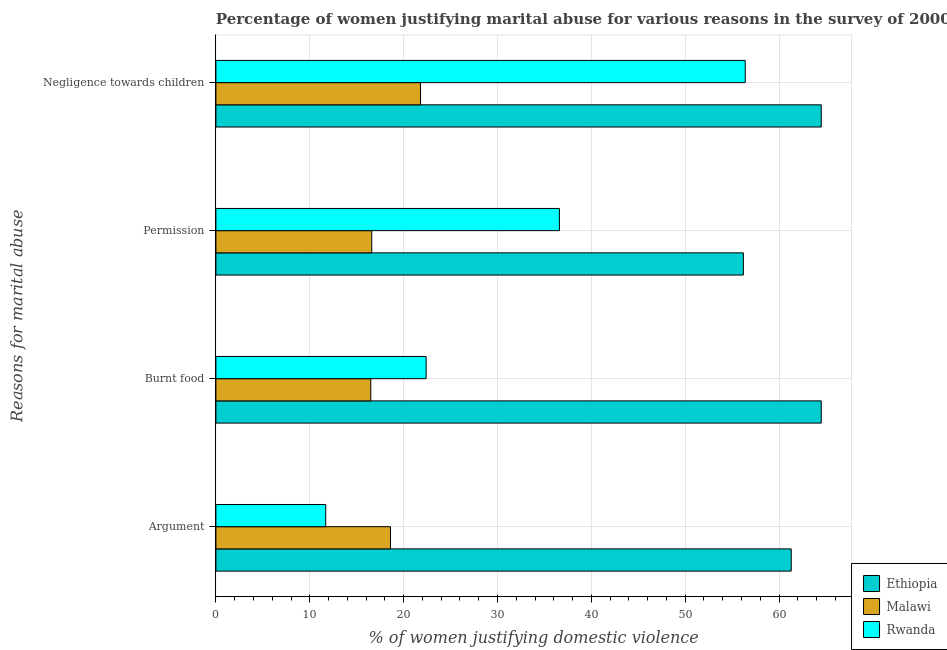How many groups of bars are there?
Offer a very short reply. 4. Are the number of bars per tick equal to the number of legend labels?
Ensure brevity in your answer.  Yes. Are the number of bars on each tick of the Y-axis equal?
Ensure brevity in your answer.  Yes. What is the label of the 3rd group of bars from the top?
Make the answer very short. Burnt food. What is the percentage of women justifying abuse for showing negligence towards children in Rwanda?
Ensure brevity in your answer.  56.4. Across all countries, what is the maximum percentage of women justifying abuse in the case of an argument?
Ensure brevity in your answer.  61.3. Across all countries, what is the minimum percentage of women justifying abuse for showing negligence towards children?
Ensure brevity in your answer.  21.8. In which country was the percentage of women justifying abuse in the case of an argument maximum?
Your answer should be compact. Ethiopia. In which country was the percentage of women justifying abuse for going without permission minimum?
Keep it short and to the point. Malawi. What is the total percentage of women justifying abuse for going without permission in the graph?
Your answer should be compact. 109.4. What is the difference between the percentage of women justifying abuse for showing negligence towards children in Rwanda and that in Ethiopia?
Provide a succinct answer. -8.1. What is the difference between the percentage of women justifying abuse for going without permission in Ethiopia and the percentage of women justifying abuse in the case of an argument in Rwanda?
Your response must be concise. 44.5. What is the average percentage of women justifying abuse for showing negligence towards children per country?
Provide a succinct answer. 47.57. What is the difference between the percentage of women justifying abuse for burning food and percentage of women justifying abuse for going without permission in Rwanda?
Keep it short and to the point. -14.2. What is the ratio of the percentage of women justifying abuse in the case of an argument in Malawi to that in Ethiopia?
Offer a terse response. 0.3. Is the difference between the percentage of women justifying abuse in the case of an argument in Ethiopia and Malawi greater than the difference between the percentage of women justifying abuse for going without permission in Ethiopia and Malawi?
Ensure brevity in your answer.  Yes. What is the difference between the highest and the second highest percentage of women justifying abuse for going without permission?
Provide a short and direct response. 19.6. Is the sum of the percentage of women justifying abuse in the case of an argument in Malawi and Ethiopia greater than the maximum percentage of women justifying abuse for going without permission across all countries?
Offer a very short reply. Yes. What does the 1st bar from the top in Negligence towards children represents?
Give a very brief answer. Rwanda. What does the 1st bar from the bottom in Negligence towards children represents?
Provide a succinct answer. Ethiopia. Does the graph contain any zero values?
Make the answer very short. No. Does the graph contain grids?
Provide a short and direct response. Yes. How are the legend labels stacked?
Offer a very short reply. Vertical. What is the title of the graph?
Keep it short and to the point. Percentage of women justifying marital abuse for various reasons in the survey of 2000. What is the label or title of the X-axis?
Provide a succinct answer. % of women justifying domestic violence. What is the label or title of the Y-axis?
Ensure brevity in your answer.  Reasons for marital abuse. What is the % of women justifying domestic violence of Ethiopia in Argument?
Offer a terse response. 61.3. What is the % of women justifying domestic violence in Rwanda in Argument?
Provide a succinct answer. 11.7. What is the % of women justifying domestic violence of Ethiopia in Burnt food?
Your response must be concise. 64.5. What is the % of women justifying domestic violence in Malawi in Burnt food?
Make the answer very short. 16.5. What is the % of women justifying domestic violence of Rwanda in Burnt food?
Provide a short and direct response. 22.4. What is the % of women justifying domestic violence of Ethiopia in Permission?
Give a very brief answer. 56.2. What is the % of women justifying domestic violence of Rwanda in Permission?
Provide a short and direct response. 36.6. What is the % of women justifying domestic violence of Ethiopia in Negligence towards children?
Give a very brief answer. 64.5. What is the % of women justifying domestic violence in Malawi in Negligence towards children?
Offer a very short reply. 21.8. What is the % of women justifying domestic violence of Rwanda in Negligence towards children?
Ensure brevity in your answer.  56.4. Across all Reasons for marital abuse, what is the maximum % of women justifying domestic violence of Ethiopia?
Ensure brevity in your answer.  64.5. Across all Reasons for marital abuse, what is the maximum % of women justifying domestic violence in Malawi?
Offer a terse response. 21.8. Across all Reasons for marital abuse, what is the maximum % of women justifying domestic violence in Rwanda?
Provide a short and direct response. 56.4. Across all Reasons for marital abuse, what is the minimum % of women justifying domestic violence of Ethiopia?
Provide a succinct answer. 56.2. Across all Reasons for marital abuse, what is the minimum % of women justifying domestic violence of Malawi?
Keep it short and to the point. 16.5. Across all Reasons for marital abuse, what is the minimum % of women justifying domestic violence of Rwanda?
Your response must be concise. 11.7. What is the total % of women justifying domestic violence in Ethiopia in the graph?
Provide a succinct answer. 246.5. What is the total % of women justifying domestic violence in Malawi in the graph?
Give a very brief answer. 73.5. What is the total % of women justifying domestic violence in Rwanda in the graph?
Your answer should be compact. 127.1. What is the difference between the % of women justifying domestic violence of Ethiopia in Argument and that in Burnt food?
Your response must be concise. -3.2. What is the difference between the % of women justifying domestic violence of Rwanda in Argument and that in Burnt food?
Ensure brevity in your answer.  -10.7. What is the difference between the % of women justifying domestic violence in Malawi in Argument and that in Permission?
Provide a succinct answer. 2. What is the difference between the % of women justifying domestic violence of Rwanda in Argument and that in Permission?
Keep it short and to the point. -24.9. What is the difference between the % of women justifying domestic violence in Ethiopia in Argument and that in Negligence towards children?
Keep it short and to the point. -3.2. What is the difference between the % of women justifying domestic violence of Malawi in Argument and that in Negligence towards children?
Your answer should be compact. -3.2. What is the difference between the % of women justifying domestic violence in Rwanda in Argument and that in Negligence towards children?
Keep it short and to the point. -44.7. What is the difference between the % of women justifying domestic violence of Ethiopia in Burnt food and that in Permission?
Provide a succinct answer. 8.3. What is the difference between the % of women justifying domestic violence of Malawi in Burnt food and that in Permission?
Offer a terse response. -0.1. What is the difference between the % of women justifying domestic violence of Rwanda in Burnt food and that in Permission?
Make the answer very short. -14.2. What is the difference between the % of women justifying domestic violence in Ethiopia in Burnt food and that in Negligence towards children?
Your answer should be compact. 0. What is the difference between the % of women justifying domestic violence in Rwanda in Burnt food and that in Negligence towards children?
Offer a terse response. -34. What is the difference between the % of women justifying domestic violence of Rwanda in Permission and that in Negligence towards children?
Offer a very short reply. -19.8. What is the difference between the % of women justifying domestic violence in Ethiopia in Argument and the % of women justifying domestic violence in Malawi in Burnt food?
Give a very brief answer. 44.8. What is the difference between the % of women justifying domestic violence in Ethiopia in Argument and the % of women justifying domestic violence in Rwanda in Burnt food?
Your answer should be compact. 38.9. What is the difference between the % of women justifying domestic violence in Malawi in Argument and the % of women justifying domestic violence in Rwanda in Burnt food?
Make the answer very short. -3.8. What is the difference between the % of women justifying domestic violence in Ethiopia in Argument and the % of women justifying domestic violence in Malawi in Permission?
Keep it short and to the point. 44.7. What is the difference between the % of women justifying domestic violence of Ethiopia in Argument and the % of women justifying domestic violence of Rwanda in Permission?
Keep it short and to the point. 24.7. What is the difference between the % of women justifying domestic violence in Malawi in Argument and the % of women justifying domestic violence in Rwanda in Permission?
Provide a short and direct response. -18. What is the difference between the % of women justifying domestic violence in Ethiopia in Argument and the % of women justifying domestic violence in Malawi in Negligence towards children?
Your answer should be very brief. 39.5. What is the difference between the % of women justifying domestic violence of Ethiopia in Argument and the % of women justifying domestic violence of Rwanda in Negligence towards children?
Offer a very short reply. 4.9. What is the difference between the % of women justifying domestic violence in Malawi in Argument and the % of women justifying domestic violence in Rwanda in Negligence towards children?
Provide a short and direct response. -37.8. What is the difference between the % of women justifying domestic violence in Ethiopia in Burnt food and the % of women justifying domestic violence in Malawi in Permission?
Keep it short and to the point. 47.9. What is the difference between the % of women justifying domestic violence of Ethiopia in Burnt food and the % of women justifying domestic violence of Rwanda in Permission?
Offer a very short reply. 27.9. What is the difference between the % of women justifying domestic violence in Malawi in Burnt food and the % of women justifying domestic violence in Rwanda in Permission?
Ensure brevity in your answer.  -20.1. What is the difference between the % of women justifying domestic violence of Ethiopia in Burnt food and the % of women justifying domestic violence of Malawi in Negligence towards children?
Make the answer very short. 42.7. What is the difference between the % of women justifying domestic violence of Ethiopia in Burnt food and the % of women justifying domestic violence of Rwanda in Negligence towards children?
Offer a very short reply. 8.1. What is the difference between the % of women justifying domestic violence of Malawi in Burnt food and the % of women justifying domestic violence of Rwanda in Negligence towards children?
Provide a short and direct response. -39.9. What is the difference between the % of women justifying domestic violence in Ethiopia in Permission and the % of women justifying domestic violence in Malawi in Negligence towards children?
Provide a succinct answer. 34.4. What is the difference between the % of women justifying domestic violence in Ethiopia in Permission and the % of women justifying domestic violence in Rwanda in Negligence towards children?
Provide a succinct answer. -0.2. What is the difference between the % of women justifying domestic violence of Malawi in Permission and the % of women justifying domestic violence of Rwanda in Negligence towards children?
Provide a succinct answer. -39.8. What is the average % of women justifying domestic violence of Ethiopia per Reasons for marital abuse?
Provide a succinct answer. 61.62. What is the average % of women justifying domestic violence in Malawi per Reasons for marital abuse?
Your answer should be very brief. 18.38. What is the average % of women justifying domestic violence in Rwanda per Reasons for marital abuse?
Ensure brevity in your answer.  31.77. What is the difference between the % of women justifying domestic violence in Ethiopia and % of women justifying domestic violence in Malawi in Argument?
Your answer should be very brief. 42.7. What is the difference between the % of women justifying domestic violence in Ethiopia and % of women justifying domestic violence in Rwanda in Argument?
Your response must be concise. 49.6. What is the difference between the % of women justifying domestic violence of Malawi and % of women justifying domestic violence of Rwanda in Argument?
Ensure brevity in your answer.  6.9. What is the difference between the % of women justifying domestic violence of Ethiopia and % of women justifying domestic violence of Rwanda in Burnt food?
Offer a terse response. 42.1. What is the difference between the % of women justifying domestic violence of Ethiopia and % of women justifying domestic violence of Malawi in Permission?
Ensure brevity in your answer.  39.6. What is the difference between the % of women justifying domestic violence in Ethiopia and % of women justifying domestic violence in Rwanda in Permission?
Your response must be concise. 19.6. What is the difference between the % of women justifying domestic violence in Ethiopia and % of women justifying domestic violence in Malawi in Negligence towards children?
Offer a very short reply. 42.7. What is the difference between the % of women justifying domestic violence of Ethiopia and % of women justifying domestic violence of Rwanda in Negligence towards children?
Keep it short and to the point. 8.1. What is the difference between the % of women justifying domestic violence in Malawi and % of women justifying domestic violence in Rwanda in Negligence towards children?
Keep it short and to the point. -34.6. What is the ratio of the % of women justifying domestic violence in Ethiopia in Argument to that in Burnt food?
Your answer should be very brief. 0.95. What is the ratio of the % of women justifying domestic violence in Malawi in Argument to that in Burnt food?
Offer a very short reply. 1.13. What is the ratio of the % of women justifying domestic violence of Rwanda in Argument to that in Burnt food?
Provide a short and direct response. 0.52. What is the ratio of the % of women justifying domestic violence of Ethiopia in Argument to that in Permission?
Provide a short and direct response. 1.09. What is the ratio of the % of women justifying domestic violence in Malawi in Argument to that in Permission?
Your answer should be very brief. 1.12. What is the ratio of the % of women justifying domestic violence of Rwanda in Argument to that in Permission?
Ensure brevity in your answer.  0.32. What is the ratio of the % of women justifying domestic violence in Ethiopia in Argument to that in Negligence towards children?
Offer a very short reply. 0.95. What is the ratio of the % of women justifying domestic violence of Malawi in Argument to that in Negligence towards children?
Your answer should be very brief. 0.85. What is the ratio of the % of women justifying domestic violence in Rwanda in Argument to that in Negligence towards children?
Provide a succinct answer. 0.21. What is the ratio of the % of women justifying domestic violence of Ethiopia in Burnt food to that in Permission?
Your response must be concise. 1.15. What is the ratio of the % of women justifying domestic violence in Rwanda in Burnt food to that in Permission?
Provide a succinct answer. 0.61. What is the ratio of the % of women justifying domestic violence in Ethiopia in Burnt food to that in Negligence towards children?
Your response must be concise. 1. What is the ratio of the % of women justifying domestic violence in Malawi in Burnt food to that in Negligence towards children?
Provide a succinct answer. 0.76. What is the ratio of the % of women justifying domestic violence of Rwanda in Burnt food to that in Negligence towards children?
Offer a terse response. 0.4. What is the ratio of the % of women justifying domestic violence of Ethiopia in Permission to that in Negligence towards children?
Offer a very short reply. 0.87. What is the ratio of the % of women justifying domestic violence in Malawi in Permission to that in Negligence towards children?
Give a very brief answer. 0.76. What is the ratio of the % of women justifying domestic violence of Rwanda in Permission to that in Negligence towards children?
Provide a succinct answer. 0.65. What is the difference between the highest and the second highest % of women justifying domestic violence in Ethiopia?
Provide a short and direct response. 0. What is the difference between the highest and the second highest % of women justifying domestic violence of Rwanda?
Keep it short and to the point. 19.8. What is the difference between the highest and the lowest % of women justifying domestic violence in Ethiopia?
Your response must be concise. 8.3. What is the difference between the highest and the lowest % of women justifying domestic violence in Rwanda?
Provide a succinct answer. 44.7. 